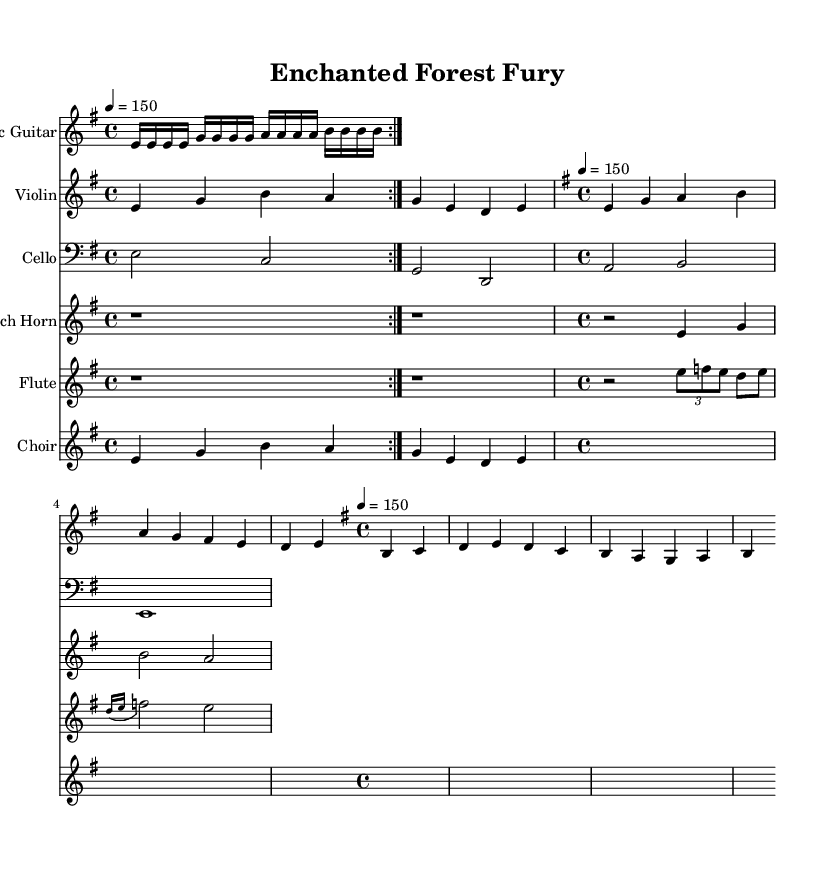What is the key signature of this music? The key signature is E minor, which has one sharp (F#) in its scale. This information can be found at the beginning of the sheet music, indicated by the key signature symbol next to the treble clef.
Answer: E minor What is the time signature of this piece? The time signature is 4/4, indicated in the sheet music by the "4/4" notation. This means there are four beats in each measure, and the quarter note gets one beat.
Answer: 4/4 What is the tempo marking for this composition? The tempo marking is marked as "4 = 150." This indicates that there are 150 beats per minute, and the quarter note is the note value that receives one beat. This is typically found above the time signature at the beginning of the sheet music.
Answer: 150 Which instrument plays the main theme? The main theme is primarily articulated by the Violin part, as indicated in the provided score. The violin plays the main theme first in the piece, followed by other instruments.
Answer: Violin How many times is the electric guitar repeated in the introduction? The electric guitar part is repeated two times in the introduction, as indicated by the "repeat volta 2" instruction in the score. This tells the musician to play the section twice before moving on.
Answer: 2 What type of musical elements are included in this symphonic metal piece? The piece incorporates orchestral elements such as strings (violin, cello), brass (french horn), woodwinds (flute), and choir, giving it a cinematic feel reminiscent of children's movie soundtracks alongside the electric guitar typical of metal genres. This combination is characteristic of symphonic metal.
Answer: Orchestral elements 